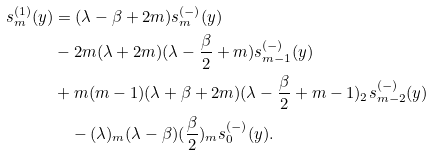<formula> <loc_0><loc_0><loc_500><loc_500>s ^ { ( 1 ) } _ { m } ( y ) & = ( \lambda - \beta + 2 m ) s ^ { ( - ) } _ { m } ( y ) \\ & - 2 m ( \lambda + 2 m ) ( \lambda - \frac { \beta } { 2 } + m ) s ^ { ( - ) } _ { m - 1 } ( y ) \\ & + m ( m - 1 ) ( \lambda + \beta + 2 m ) ( \lambda - \frac { \beta } { 2 } + m - 1 ) _ { 2 } s ^ { ( - ) } _ { m - 2 } ( y ) \\ & \quad - ( \lambda ) _ { m } ( \lambda - \beta ) ( \frac { \beta } { 2 } ) _ { m } s ^ { ( - ) } _ { 0 } ( y ) .</formula> 